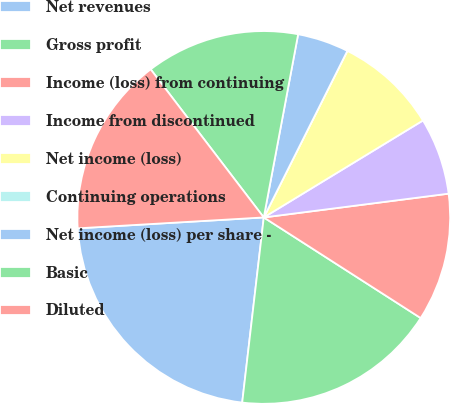<chart> <loc_0><loc_0><loc_500><loc_500><pie_chart><fcel>Net revenues<fcel>Gross profit<fcel>Income (loss) from continuing<fcel>Income from discontinued<fcel>Net income (loss)<fcel>Continuing operations<fcel>Net income (loss) per share -<fcel>Basic<fcel>Diluted<nl><fcel>22.22%<fcel>17.77%<fcel>11.11%<fcel>6.67%<fcel>8.89%<fcel>0.0%<fcel>4.45%<fcel>13.33%<fcel>15.55%<nl></chart> 